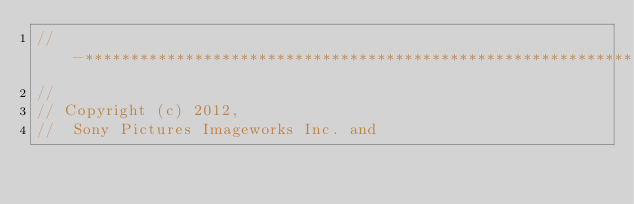<code> <loc_0><loc_0><loc_500><loc_500><_C++_>//-*****************************************************************************
//
// Copyright (c) 2012,
//  Sony Pictures Imageworks Inc. and</code> 